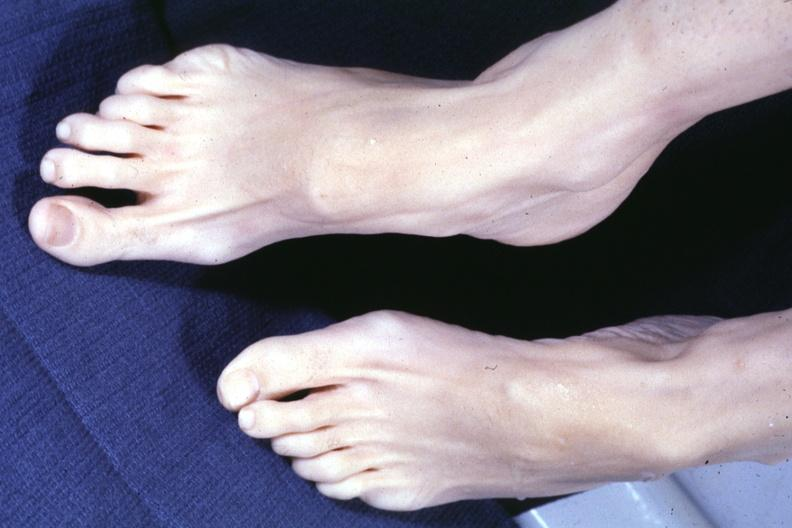what see other slide this interesting case?
Answer the question using a single word or phrase. No cystic aortic lesions 